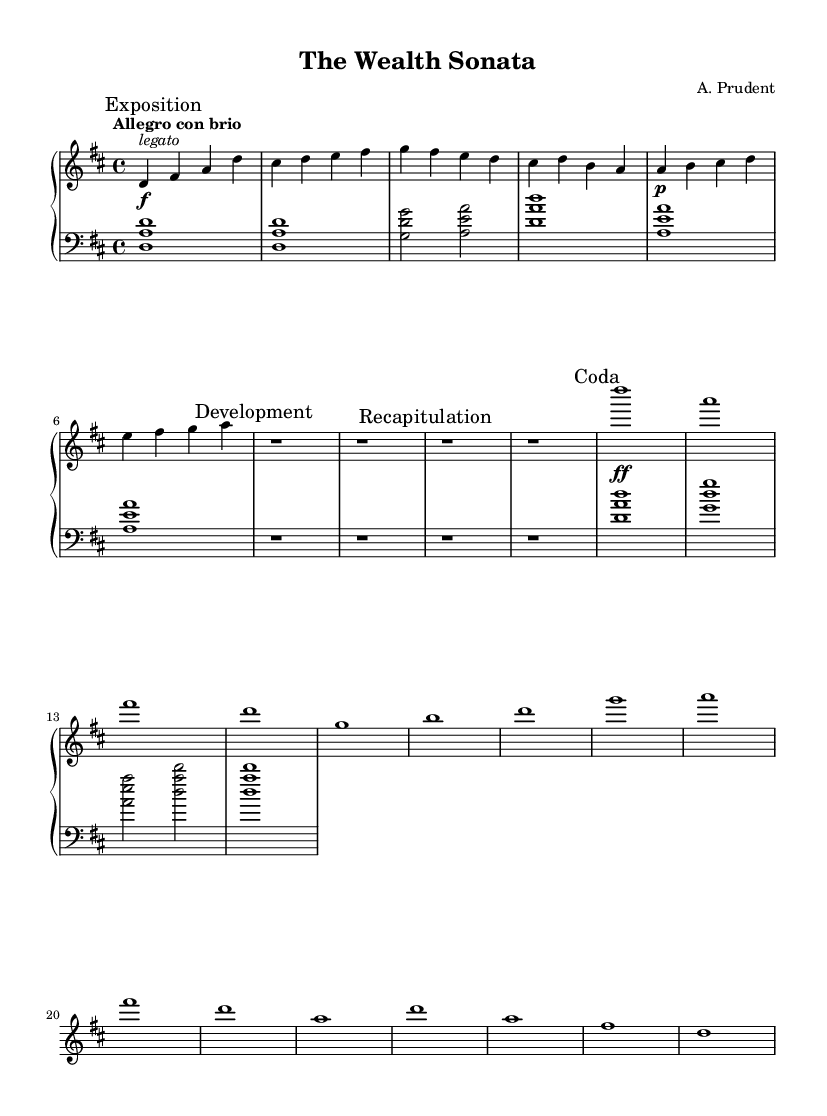What is the key signature of this music? The key signature is D major, which has two sharps: F# and C#.
Answer: D major What is the time signature of this music? The time signature is 4/4, indicating there are four beats in each measure and each quarter note gets one beat.
Answer: 4/4 What is the tempo marking for this piece? The tempo marking is "Allegro con brio," which indicates a fast tempo with vigor.
Answer: Allegro con brio What is the dynamic marking of the first theme? The dynamic marking for the first theme is forte, indicated by the "f" symbol in the score.
Answer: forte What are the two main sections named in the sonata? The two main sections are the "Exposition" and the "Development," which are standard in sonata form.
Answer: Exposition and Development In what section does the Coda appear? The Coda appears after the Recapitulation, and it serves as the concluding section of the sonata.
Answer: Coda How many measures constitute the Exposition's first theme? The first theme of the Exposition consists of eight measures, as indicated by the notation in the score.
Answer: Eight measures 